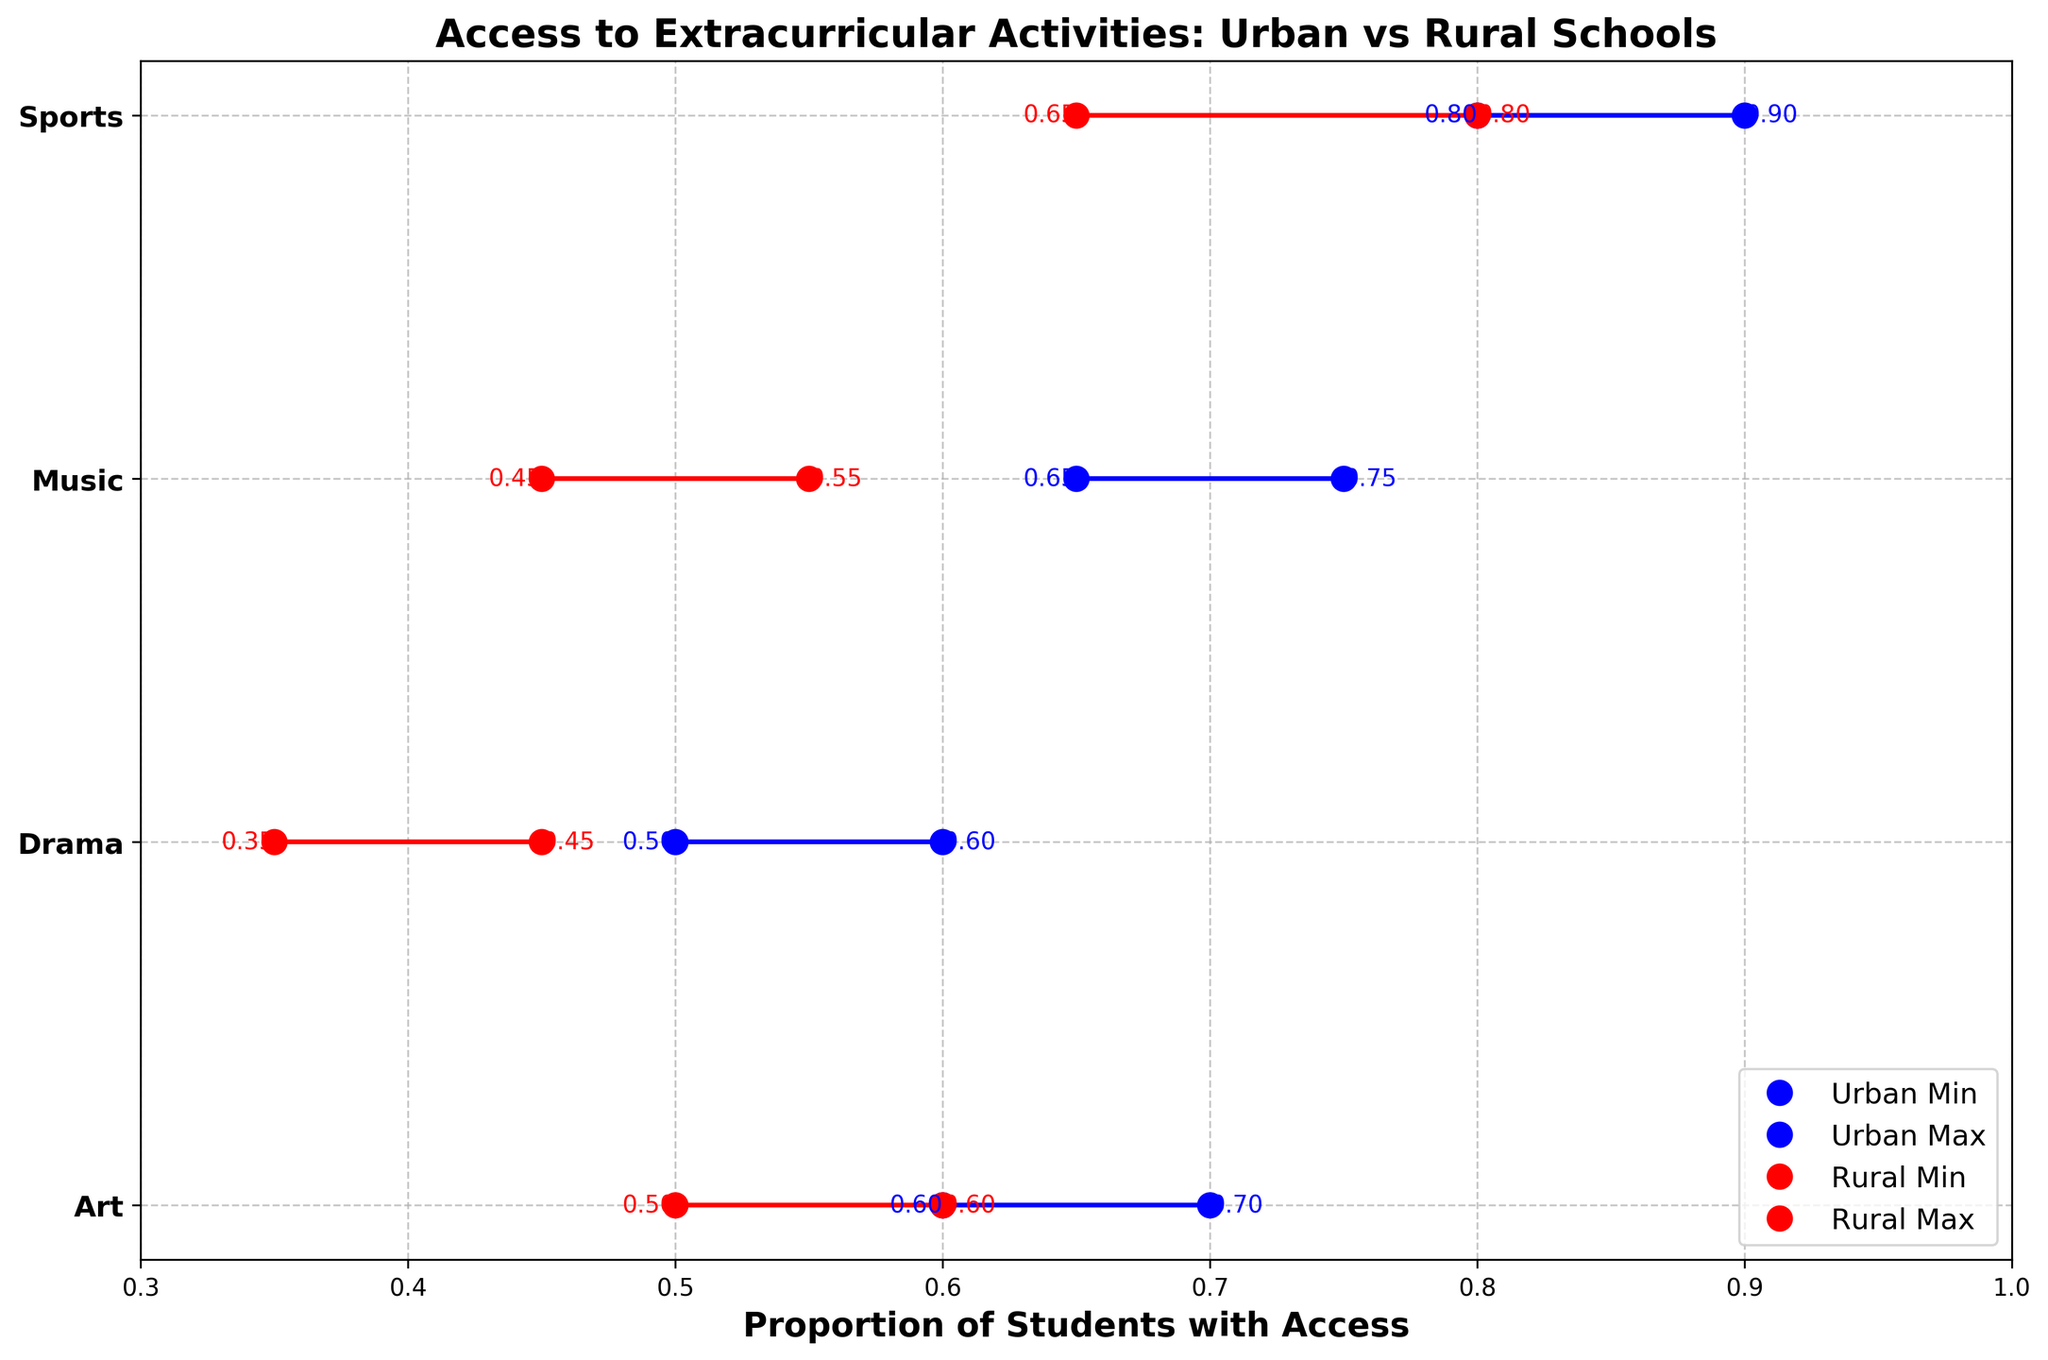What is the title of the plot? The title of the plot is located at the top of the figure. It is written in larger font size and we can see that it states "Access to Extracurricular Activities: Urban vs Rural Schools".
Answer: Access to Extracurricular Activities: Urban vs Rural Schools What are the y-axis labels in the plot? The y-axis labels represent different extracurricular activities, which can be observed running along the left side of the plot. These labels are 'Sports', 'Music', 'Art', and 'Drama'.
Answer: Sports, Music, Art, Drama Which activity shows the highest minimum proportion for Urban schools? To determine this, look at the blue dots labeled "Urban Min" and identify the highest dot value among them. The highest blue "Urban Min" proportion appears next to 'Sports'.
Answer: Sports What are the minimum and maximum proportions of Urban schools for 'Drama'? Locate the activity 'Drama' on the y-axis and then find the corresponding blue dots. These dots should show the minimum and maximum proportions: 0.50 and 0.60.
Answer: 0.50 and 0.60 How do the minimum and maximum proportions of Rural schools for 'Art' compare? Look at the red dots for 'Art' on the y-axis. The red lines connect these dots, showing a range from 0.50 to 0.60.
Answer: 0.50 to 0.60 Calculate the range of proportions for Urban schools offering 'Music'. To find this, identify the minimum and maximum proportions for 'Music' among Urban schools by finding the blue dots next to 'Music'. The range is calculated as 0.75 - 0.65 = 0.10.
Answer: 0.10 Which extracurricular activity has a greater difference between the maximum proportions of Urban and Rural schools? Compare the maximum proportions for each activity by looking at the blue and red lines. 'Sports' shows the greatest difference as Urban max (0.90) and Rural max (0.80). The difference is 0.10.
Answer: Sports Which type of school generally offers more access to extracurricular activities? By observing overall trends, Urban schools (blue dots) generally have higher proportions for most activities compared to Rural schools (red dots). This includes higher minimums and maximums.
Answer: Urban schools What is the average minimum proportion of Rural schools across all activities? Calculate the mean of the minimum proportions for Rural schools by looking at the leftmost red dots for each activity: (0.70 + 0.65 + 0.80 + 0.55 + 0.50 + 0.45) / 6 = 0.61.
Answer: 0.61 